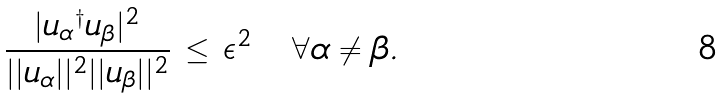Convert formula to latex. <formula><loc_0><loc_0><loc_500><loc_500>\frac { | { { u } _ { \alpha } } ^ { \dagger } { { u } _ { \beta } } | ^ { 2 } } { | | { u } _ { \alpha } | | ^ { 2 } | | { u } _ { \beta } | | ^ { 2 } } \, \leq \, \epsilon ^ { 2 } \quad \forall \alpha \neq \beta .</formula> 